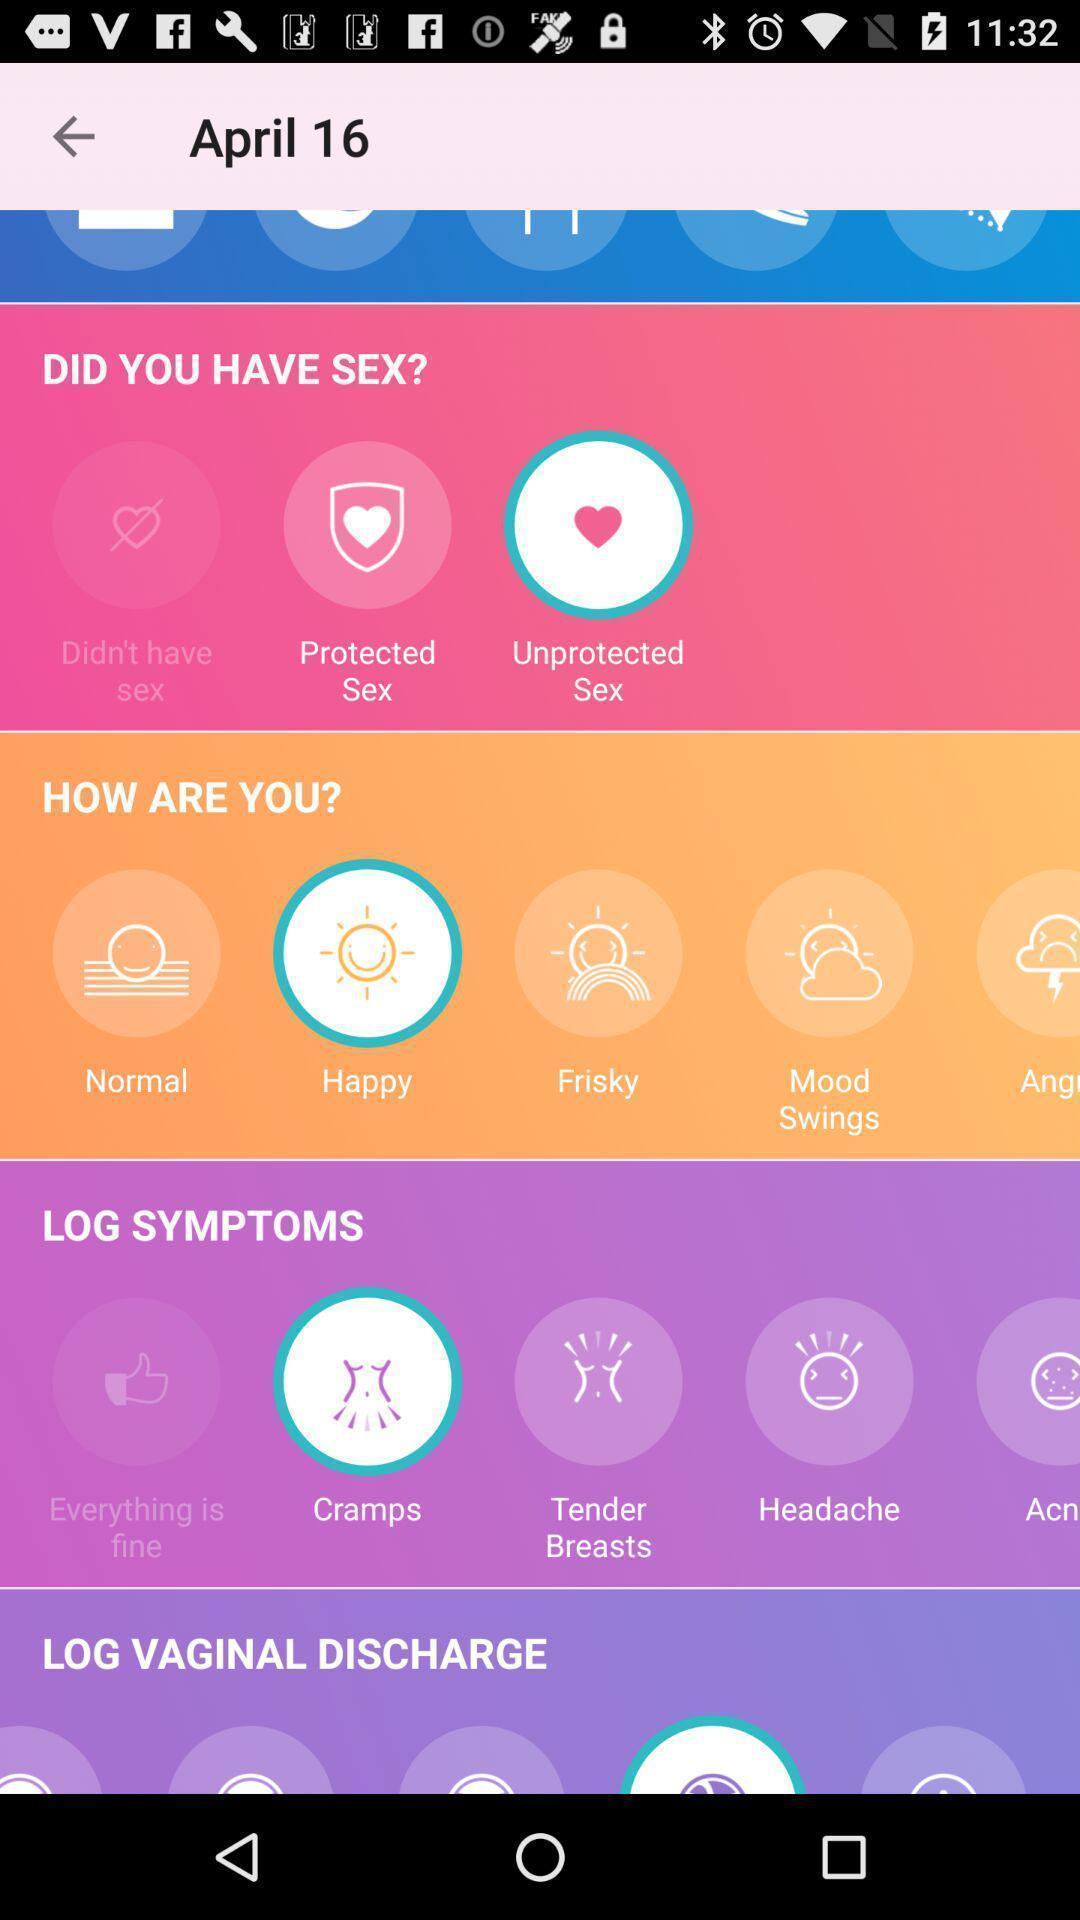Explain the elements present in this screenshot. Various preferences displayed on particular date of health care app. 